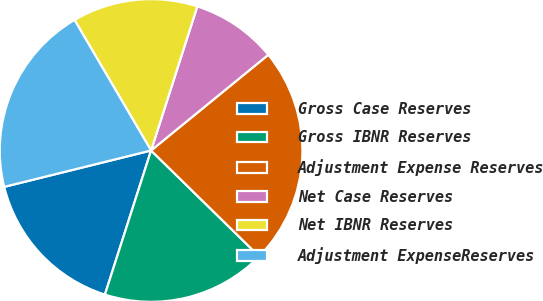Convert chart to OTSL. <chart><loc_0><loc_0><loc_500><loc_500><pie_chart><fcel>Gross Case Reserves<fcel>Gross IBNR Reserves<fcel>Adjustment Expense Reserves<fcel>Net Case Reserves<fcel>Net IBNR Reserves<fcel>Adjustment ExpenseReserves<nl><fcel>16.2%<fcel>17.6%<fcel>23.23%<fcel>9.16%<fcel>13.38%<fcel>20.42%<nl></chart> 